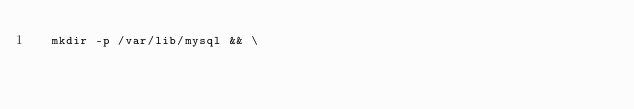<code> <loc_0><loc_0><loc_500><loc_500><_Dockerfile_>	mkdir -p /var/lib/mysql && \</code> 